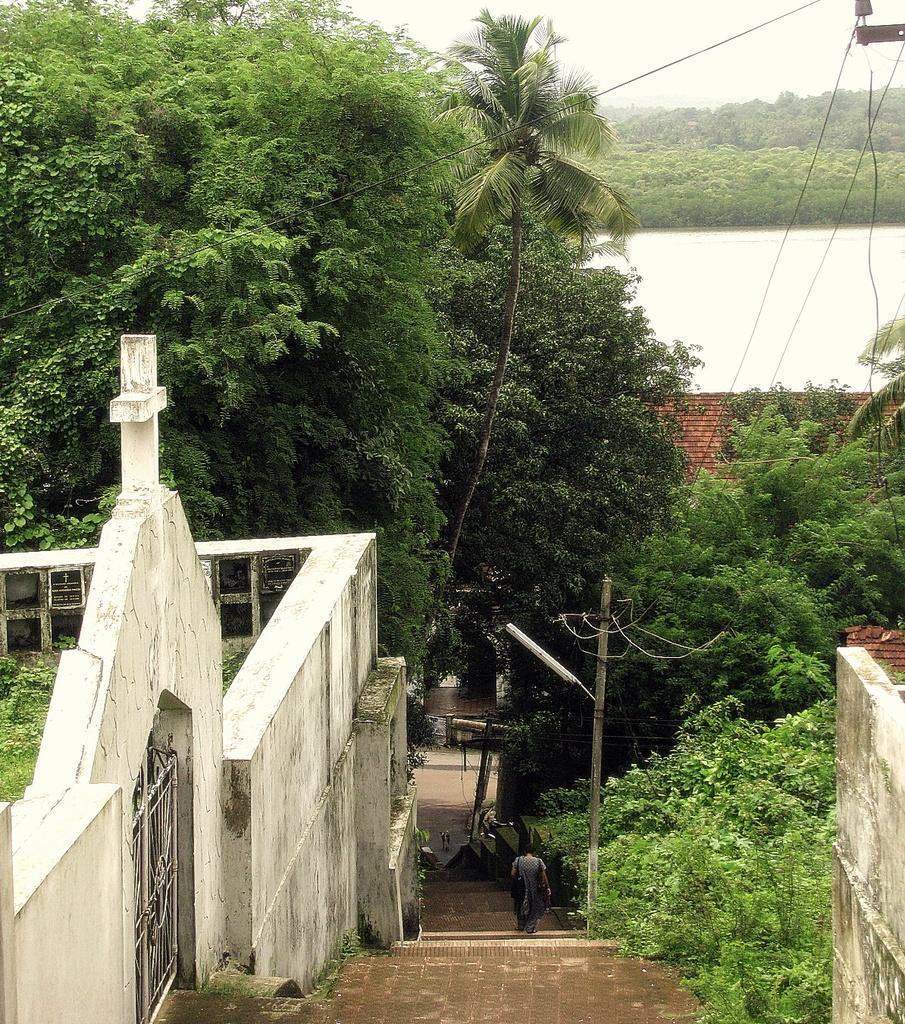Could you give a brief overview of what you see in this image? In this image there are trees and we can see buildings. There is water and we can see wires. In the background there is sky and we can see stairs. There is a person. 